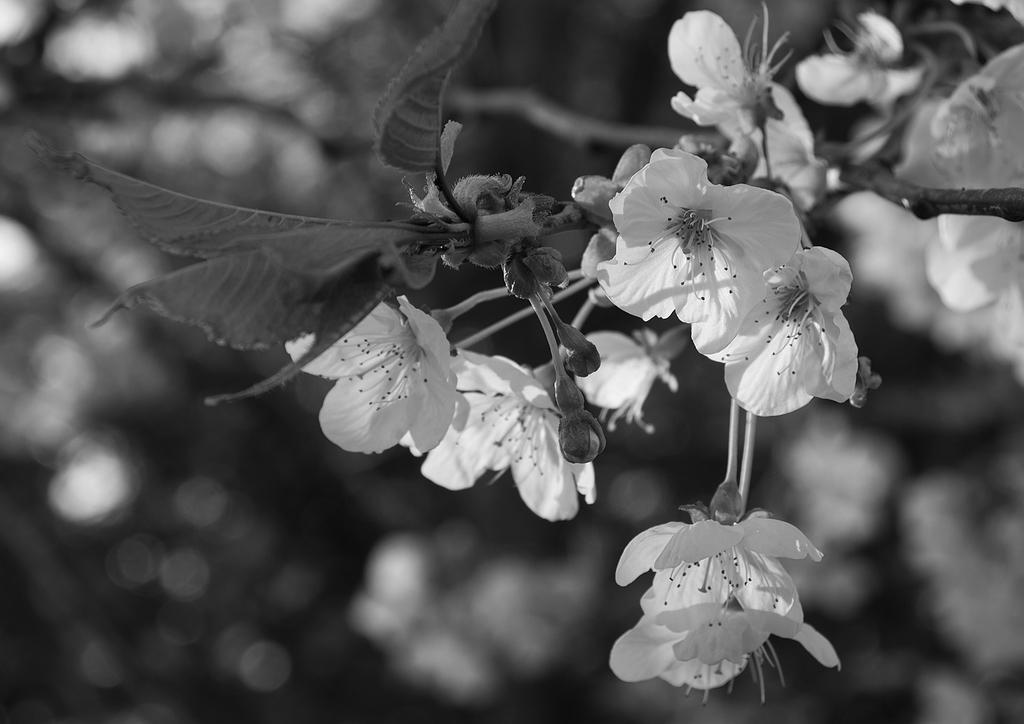What is the color scheme of the image? The image is black and white. What can be seen on the right side of the image? There are branches of a tree on the right side of the image. What are the characteristics of the tree branches? The tree branches have leaves, fruits, and flowers. How would you describe the background of the image? The background of the image is blurred. What type of flame can be seen on the tree branches in the image? There is no flame present on the tree branches in the image. Does the existence of the tree branches in the image prove the existence of a parallel universe? The presence of tree branches in the image does not prove the existence of a parallel universe; it is simply a depiction of a tree in a photograph. 